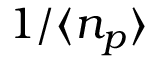<formula> <loc_0><loc_0><loc_500><loc_500>1 / \langle n _ { p } \rangle</formula> 